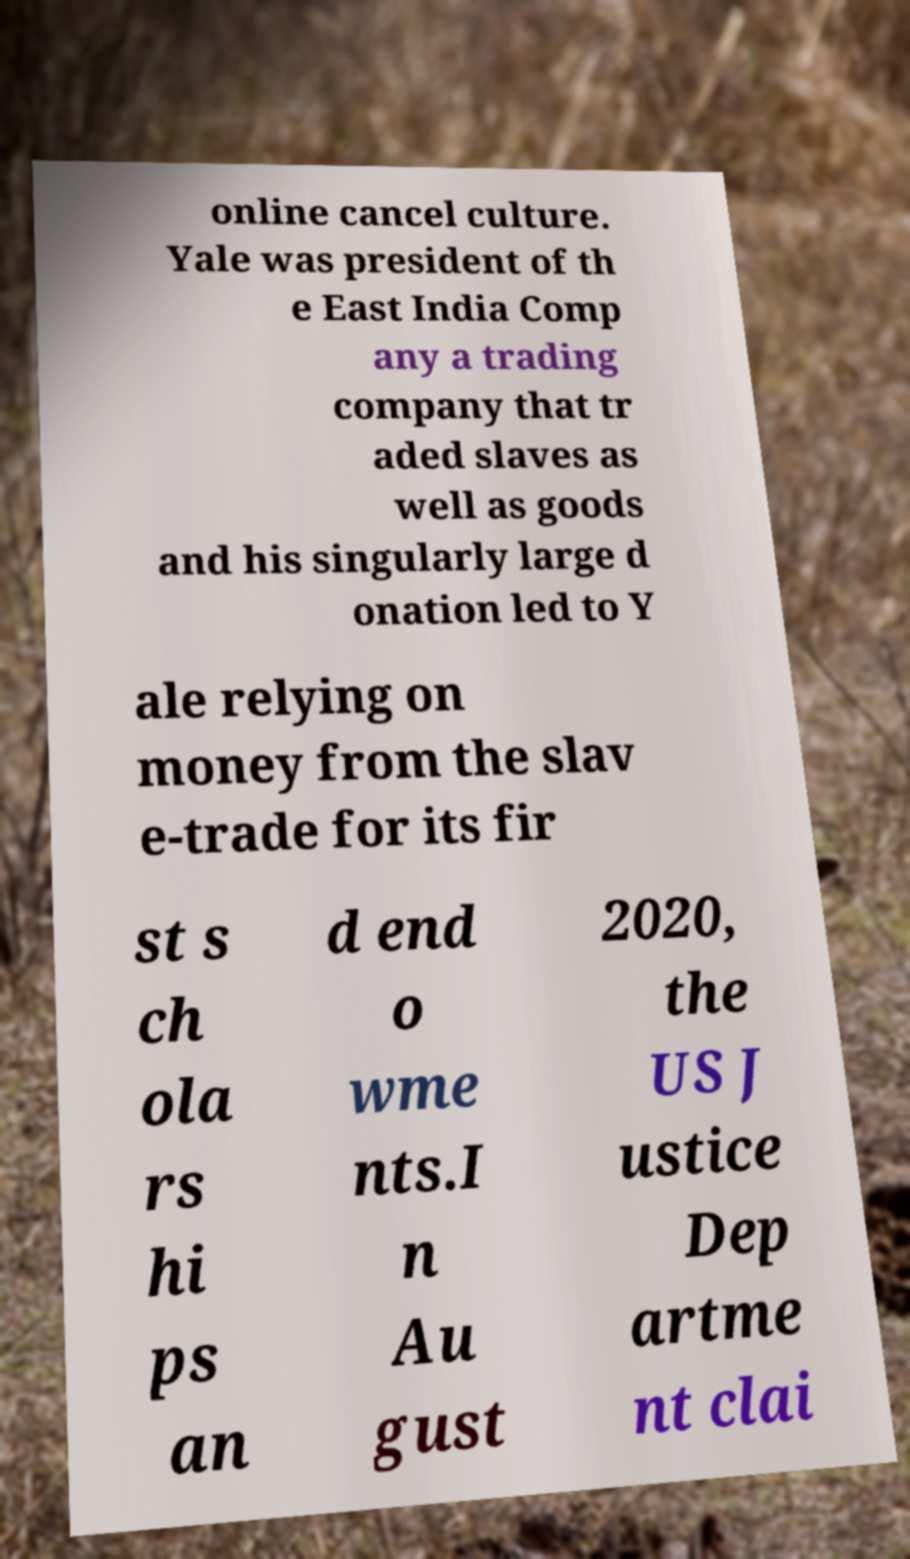There's text embedded in this image that I need extracted. Can you transcribe it verbatim? online cancel culture. Yale was president of th e East India Comp any a trading company that tr aded slaves as well as goods and his singularly large d onation led to Y ale relying on money from the slav e-trade for its fir st s ch ola rs hi ps an d end o wme nts.I n Au gust 2020, the US J ustice Dep artme nt clai 